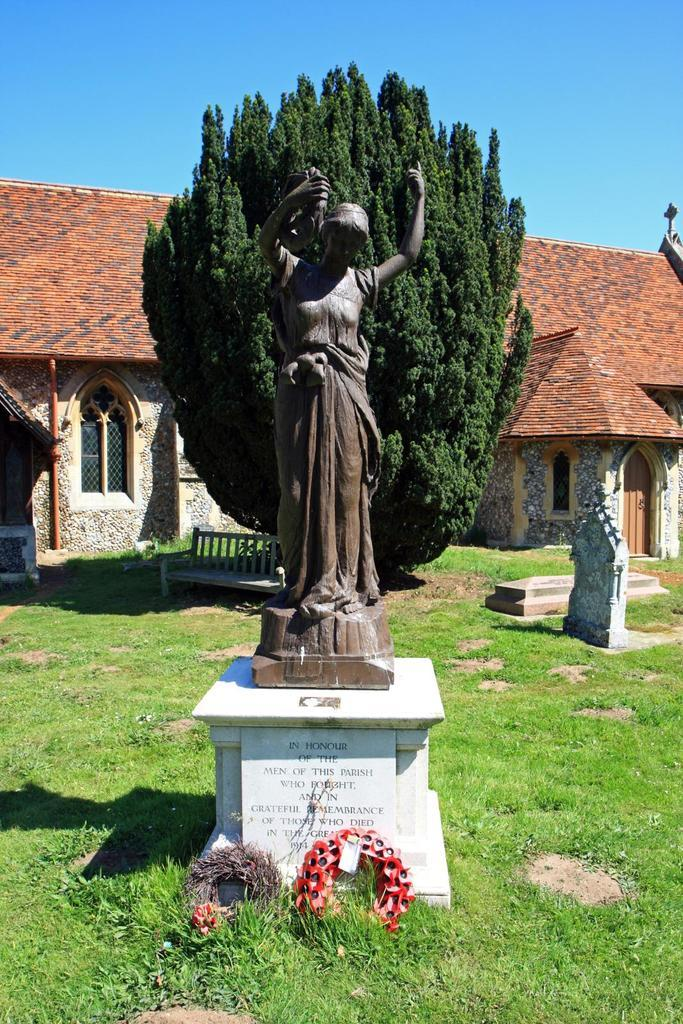What is the main subject of the image? There is a statue in the image. How is the statue positioned in the image? The statue is on a pedestal. What can be seen on the ground near the statue? There are wreaths on the ground in the image. What type of seating is present in the image? There is a bench in the image. What type of structure is visible in the image? There is a building in the image. What type of pathway is present in the image? There are laid stones in the image. What type of memorial is depicted in the image? There is a grave in the image. What can be seen in the background of the image? The sky is visible in the background of the image. What type of mark can be seen on the cherry in the image? There is no cherry present in the image, so it is not possible to determine if there is a mark on it. What type of hat is the statue wearing in the image? The statue does not appear to be wearing a hat in the image. 